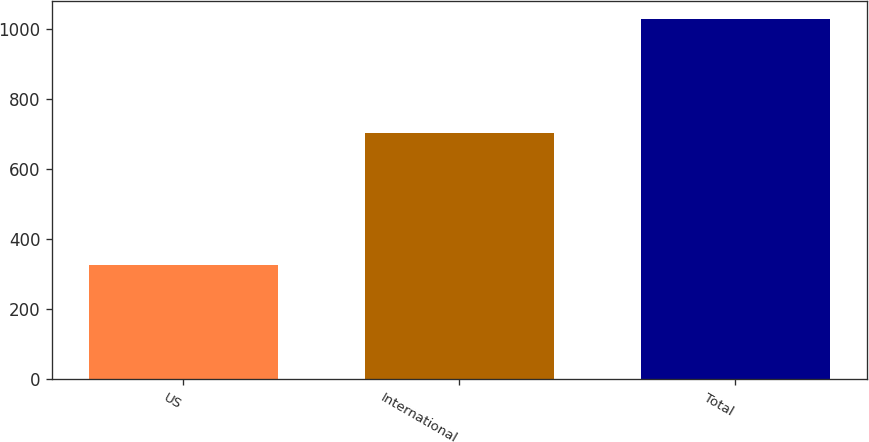Convert chart to OTSL. <chart><loc_0><loc_0><loc_500><loc_500><bar_chart><fcel>US<fcel>International<fcel>Total<nl><fcel>326<fcel>704<fcel>1030<nl></chart> 